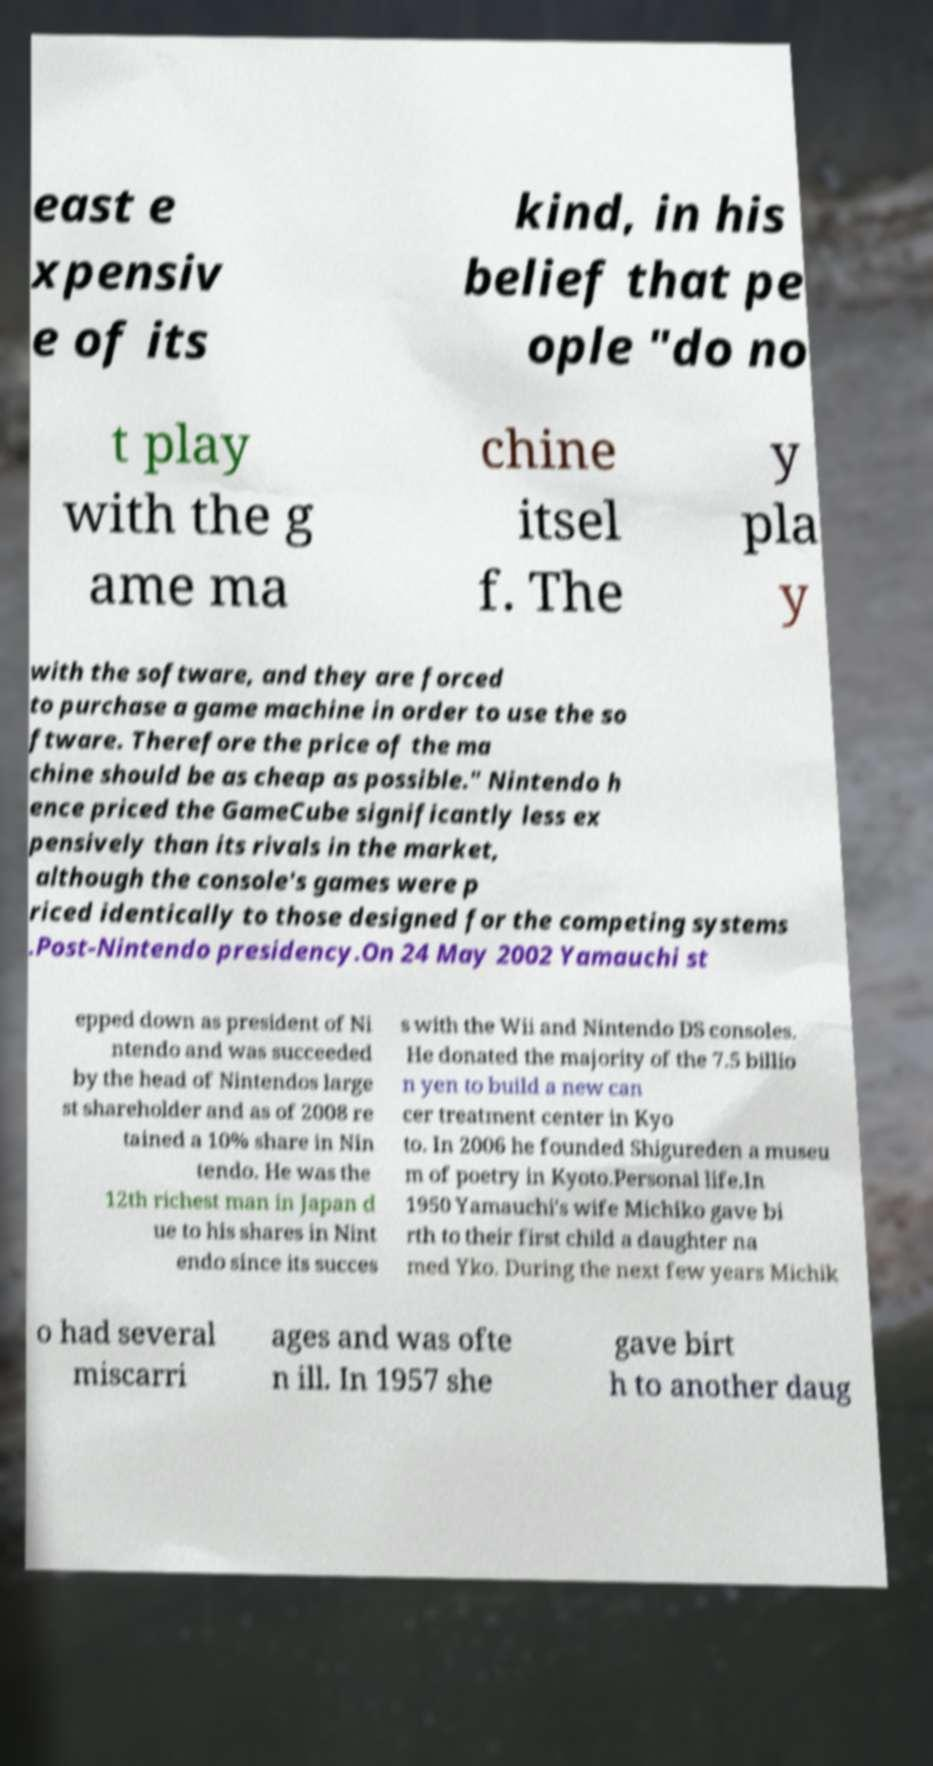What messages or text are displayed in this image? I need them in a readable, typed format. east e xpensiv e of its kind, in his belief that pe ople "do no t play with the g ame ma chine itsel f. The y pla y with the software, and they are forced to purchase a game machine in order to use the so ftware. Therefore the price of the ma chine should be as cheap as possible." Nintendo h ence priced the GameCube significantly less ex pensively than its rivals in the market, although the console's games were p riced identically to those designed for the competing systems .Post-Nintendo presidency.On 24 May 2002 Yamauchi st epped down as president of Ni ntendo and was succeeded by the head of Nintendos large st shareholder and as of 2008 re tained a 10% share in Nin tendo. He was the 12th richest man in Japan d ue to his shares in Nint endo since its succes s with the Wii and Nintendo DS consoles. He donated the majority of the 7.5 billio n yen to build a new can cer treatment center in Kyo to. In 2006 he founded Shigureden a museu m of poetry in Kyoto.Personal life.In 1950 Yamauchi's wife Michiko gave bi rth to their first child a daughter na med Yko. During the next few years Michik o had several miscarri ages and was ofte n ill. In 1957 she gave birt h to another daug 